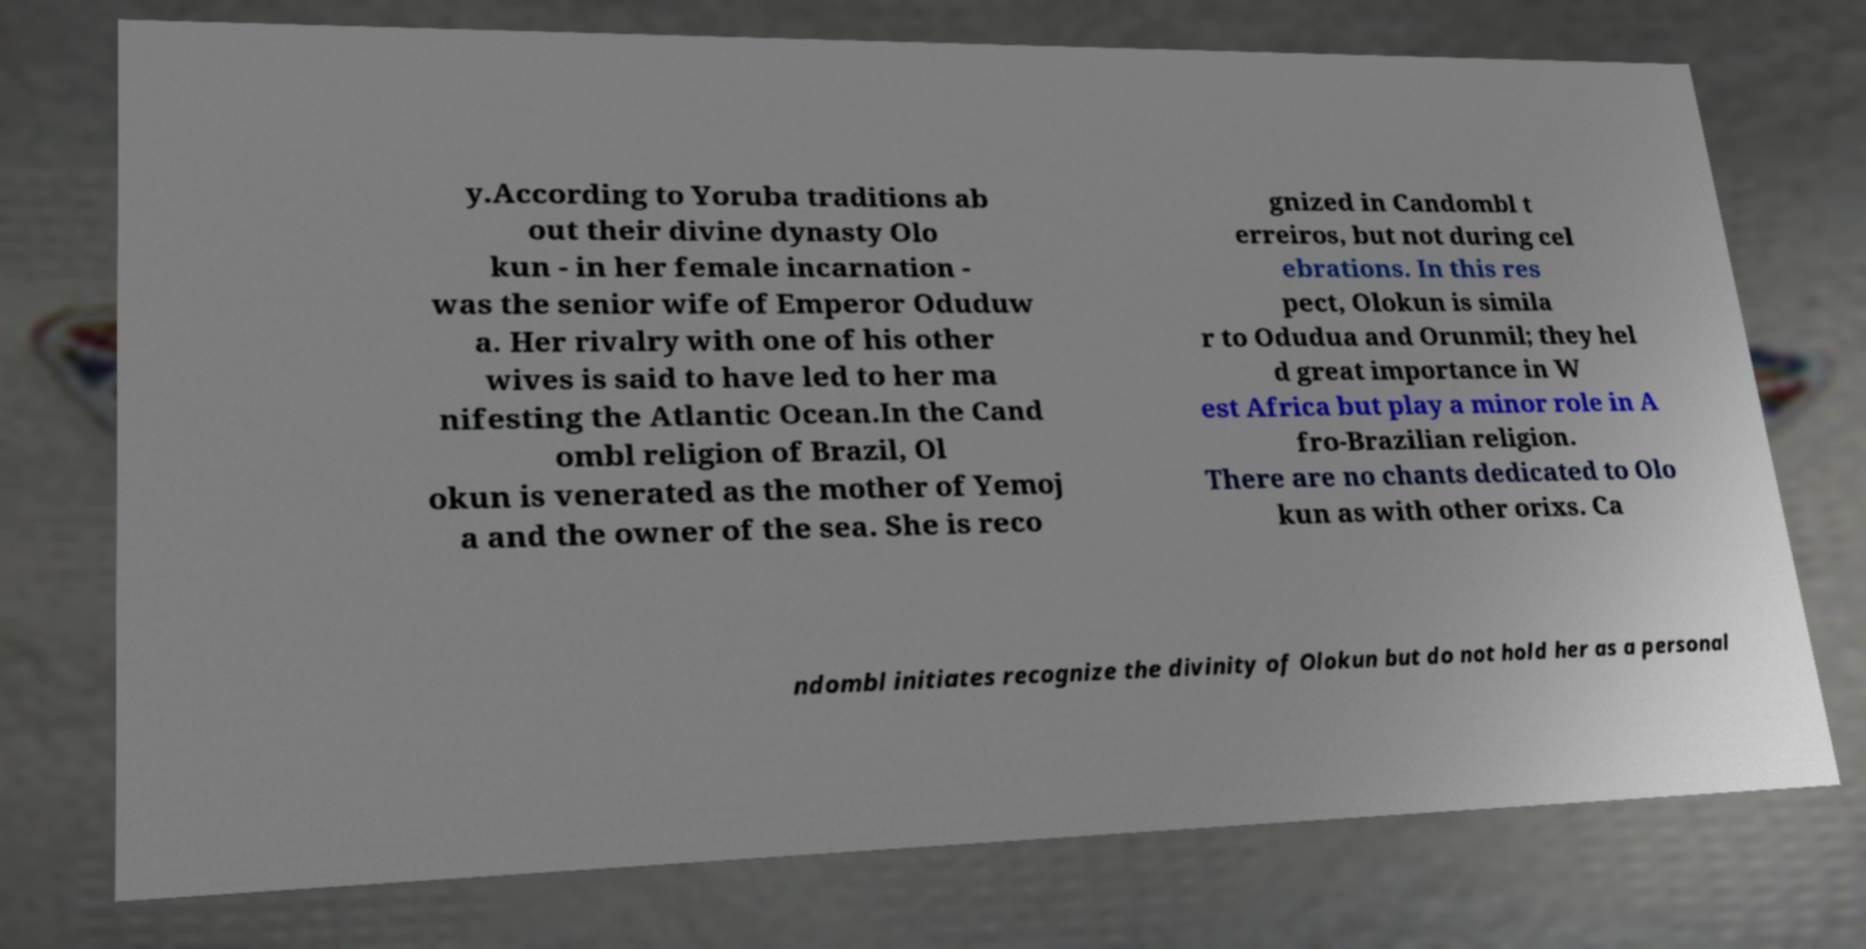Can you read and provide the text displayed in the image?This photo seems to have some interesting text. Can you extract and type it out for me? y.According to Yoruba traditions ab out their divine dynasty Olo kun - in her female incarnation - was the senior wife of Emperor Oduduw a. Her rivalry with one of his other wives is said to have led to her ma nifesting the Atlantic Ocean.In the Cand ombl religion of Brazil, Ol okun is venerated as the mother of Yemoj a and the owner of the sea. She is reco gnized in Candombl t erreiros, but not during cel ebrations. In this res pect, Olokun is simila r to Odudua and Orunmil; they hel d great importance in W est Africa but play a minor role in A fro-Brazilian religion. There are no chants dedicated to Olo kun as with other orixs. Ca ndombl initiates recognize the divinity of Olokun but do not hold her as a personal 